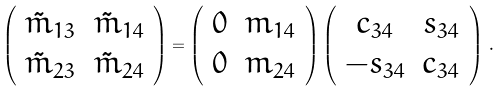Convert formula to latex. <formula><loc_0><loc_0><loc_500><loc_500>\left ( \begin{array} { c c } \tilde { m } _ { 1 3 } & \tilde { m } _ { 1 4 } \\ \tilde { m } _ { 2 3 } & \tilde { m } _ { 2 4 } \end{array} \right ) = \left ( \begin{array} { c c } 0 & m _ { 1 4 } \\ 0 & m _ { 2 4 } \end{array} \right ) \left ( \begin{array} { c c } c _ { 3 4 } & s _ { 3 4 } \\ - s _ { 3 4 } & c _ { 3 4 } \end{array} \right ) \, .</formula> 